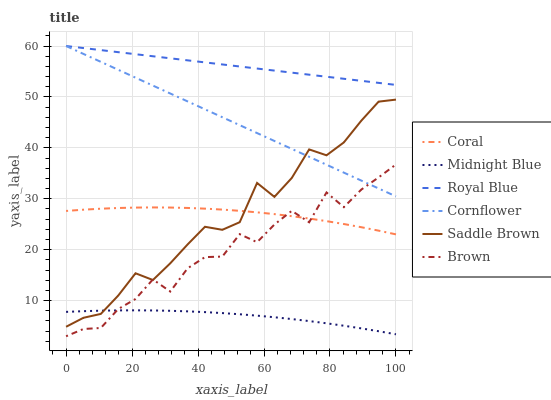Does Midnight Blue have the minimum area under the curve?
Answer yes or no. Yes. Does Royal Blue have the maximum area under the curve?
Answer yes or no. Yes. Does Cornflower have the minimum area under the curve?
Answer yes or no. No. Does Cornflower have the maximum area under the curve?
Answer yes or no. No. Is Royal Blue the smoothest?
Answer yes or no. Yes. Is Brown the roughest?
Answer yes or no. Yes. Is Midnight Blue the smoothest?
Answer yes or no. No. Is Midnight Blue the roughest?
Answer yes or no. No. Does Brown have the lowest value?
Answer yes or no. Yes. Does Midnight Blue have the lowest value?
Answer yes or no. No. Does Royal Blue have the highest value?
Answer yes or no. Yes. Does Midnight Blue have the highest value?
Answer yes or no. No. Is Midnight Blue less than Royal Blue?
Answer yes or no. Yes. Is Cornflower greater than Coral?
Answer yes or no. Yes. Does Coral intersect Brown?
Answer yes or no. Yes. Is Coral less than Brown?
Answer yes or no. No. Is Coral greater than Brown?
Answer yes or no. No. Does Midnight Blue intersect Royal Blue?
Answer yes or no. No. 